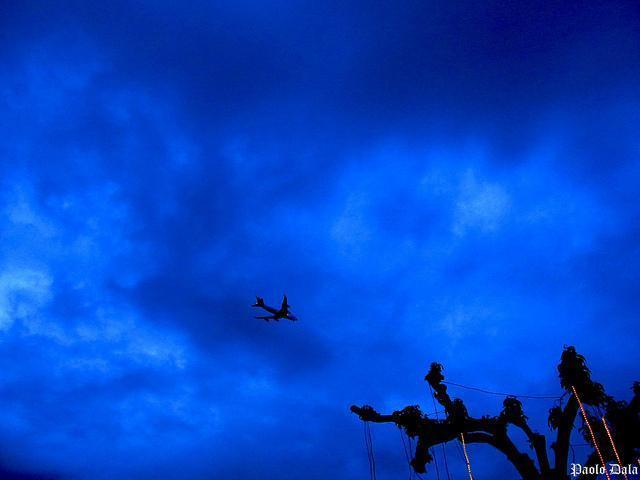How many birds are in the air?
Give a very brief answer. 0. How many airplanes are there?
Give a very brief answer. 1. 